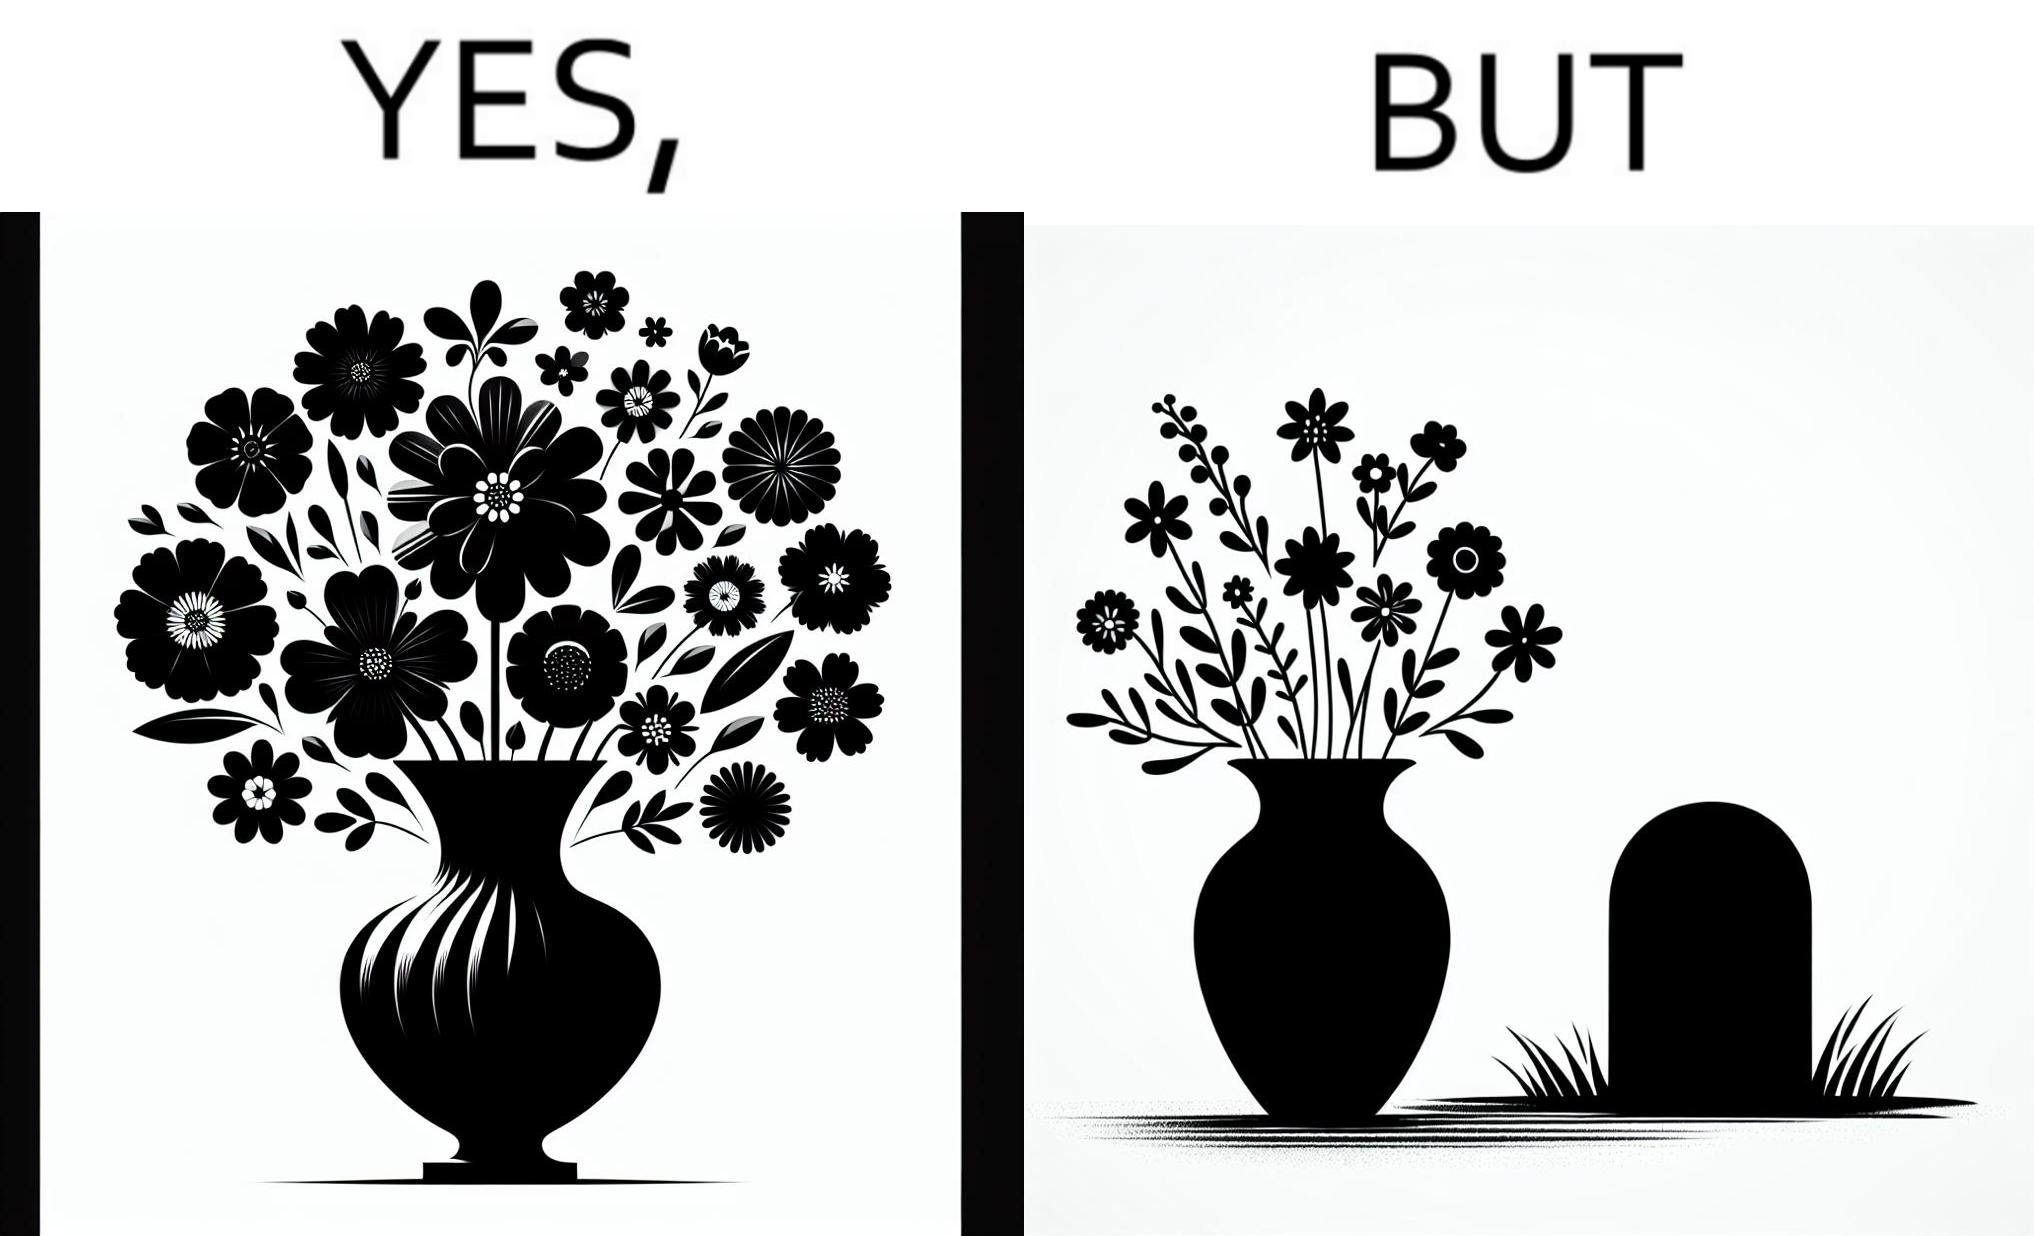What is shown in this image? The image is ironic, because in the first image a vase full of different beautiful flowers is seen which spreads a feeling of positivity, cheerfulness etc., whereas in the second image when the same vase is put in front of a grave stone it produces a feeling of sorrow 